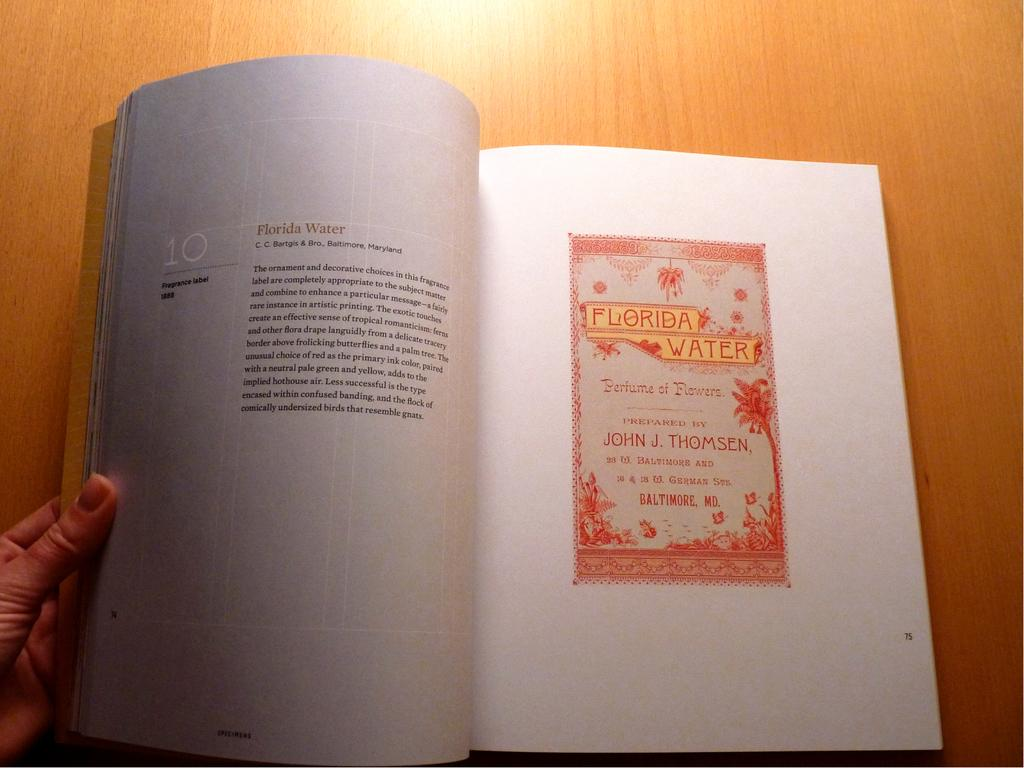Provide a one-sentence caption for the provided image. A book opened to a page about Florida water. 